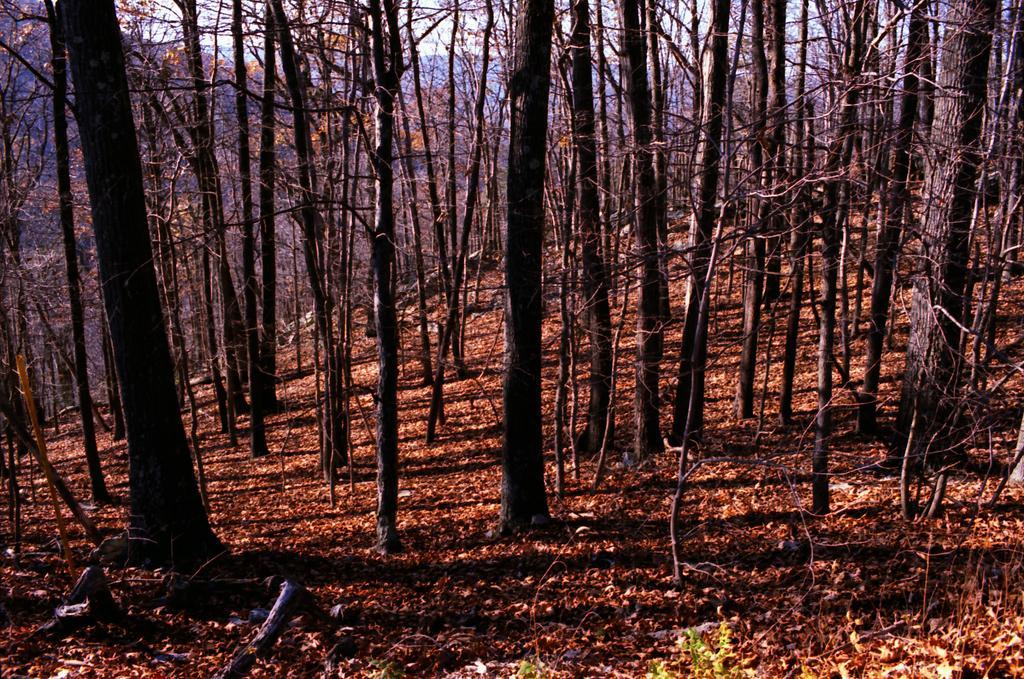Can you describe this image briefly? In this picture I can see some trees, some dry leaves on the floor. 